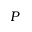<formula> <loc_0><loc_0><loc_500><loc_500>P</formula> 